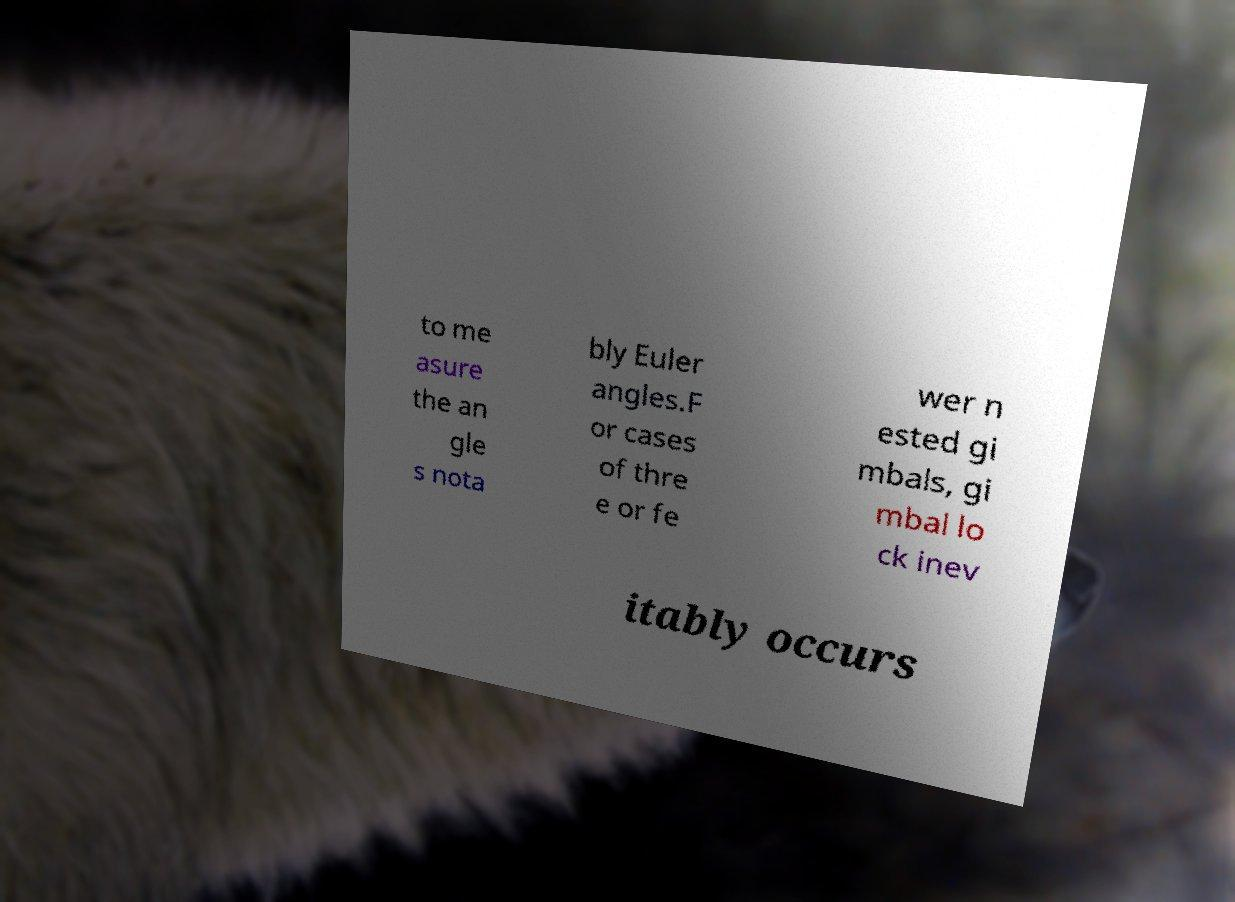Could you extract and type out the text from this image? to me asure the an gle s nota bly Euler angles.F or cases of thre e or fe wer n ested gi mbals, gi mbal lo ck inev itably occurs 